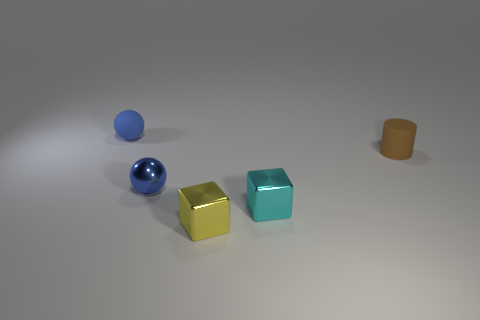Do the shiny sphere and the rubber ball have the same color?
Your answer should be compact. Yes. Are there more small yellow shiny cubes that are in front of the tiny blue metal ball than cyan cylinders?
Offer a very short reply. Yes. Is the number of blue shiny objects that are in front of the cyan thing the same as the number of blue balls that are in front of the cylinder?
Provide a short and direct response. No. Are there any small rubber things that are right of the shiny block that is right of the tiny yellow metal object?
Ensure brevity in your answer.  Yes. The cyan metallic object is what shape?
Provide a short and direct response. Cube. What size is the matte object left of the tiny block behind the yellow cube?
Ensure brevity in your answer.  Small. What is the size of the matte object right of the shiny ball?
Your answer should be very brief. Small. Is the number of small cyan metal objects behind the brown object less than the number of tiny metallic objects that are to the left of the yellow thing?
Make the answer very short. Yes. What is the color of the small matte cylinder?
Give a very brief answer. Brown. Is there another ball that has the same color as the rubber sphere?
Offer a terse response. Yes. 